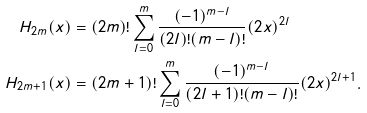Convert formula to latex. <formula><loc_0><loc_0><loc_500><loc_500>H _ { 2 m } ( x ) & = ( 2 m ) ! \sum _ { l = 0 } ^ { m } \frac { ( - 1 ) ^ { m - l } } { ( 2 l ) ! ( m - l ) ! } ( 2 x ) ^ { 2 l } \\ H _ { 2 m + 1 } ( x ) & = ( 2 m + 1 ) ! \sum _ { l = 0 } ^ { m } \frac { ( - 1 ) ^ { m - l } } { ( 2 l + 1 ) ! ( m - l ) ! } ( 2 x ) ^ { 2 l + 1 } .</formula> 